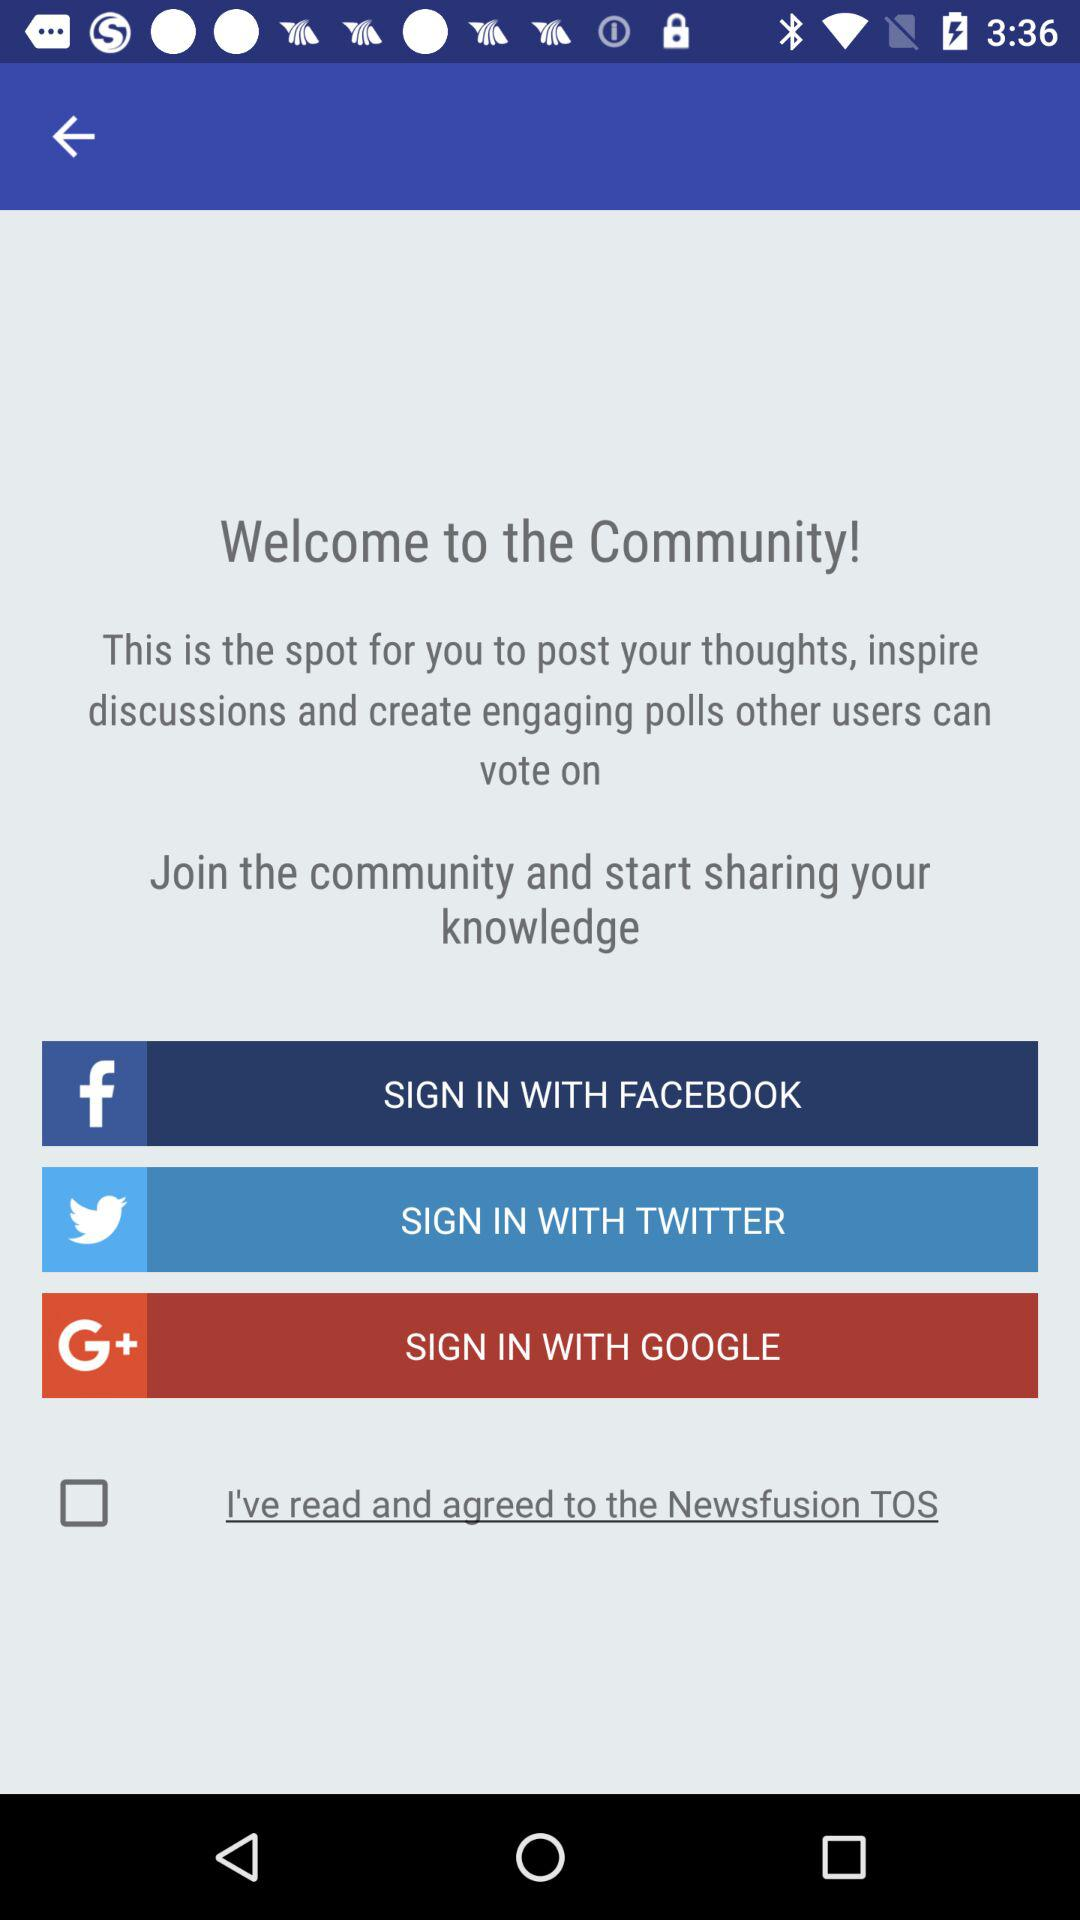What are the different applications through which we can sign in? The different applications through which you can sign in are "FACEBOOK", "TWITTER" and "GOOGLE". 